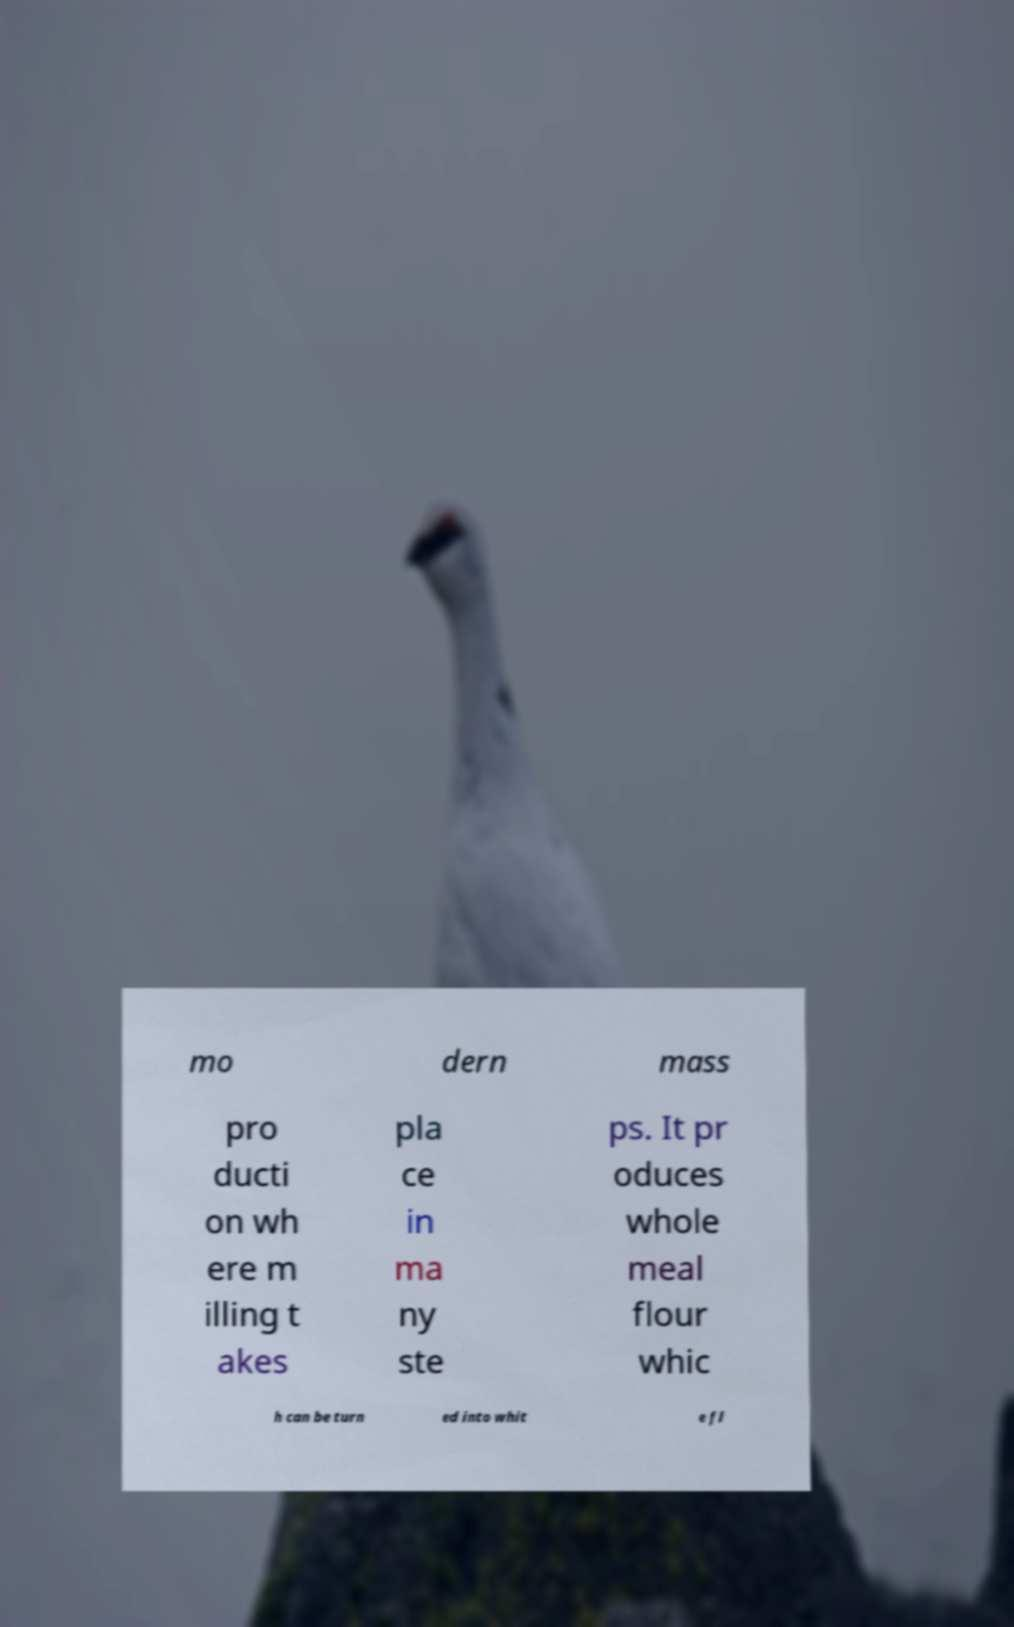Could you assist in decoding the text presented in this image and type it out clearly? mo dern mass pro ducti on wh ere m illing t akes pla ce in ma ny ste ps. It pr oduces whole meal flour whic h can be turn ed into whit e fl 